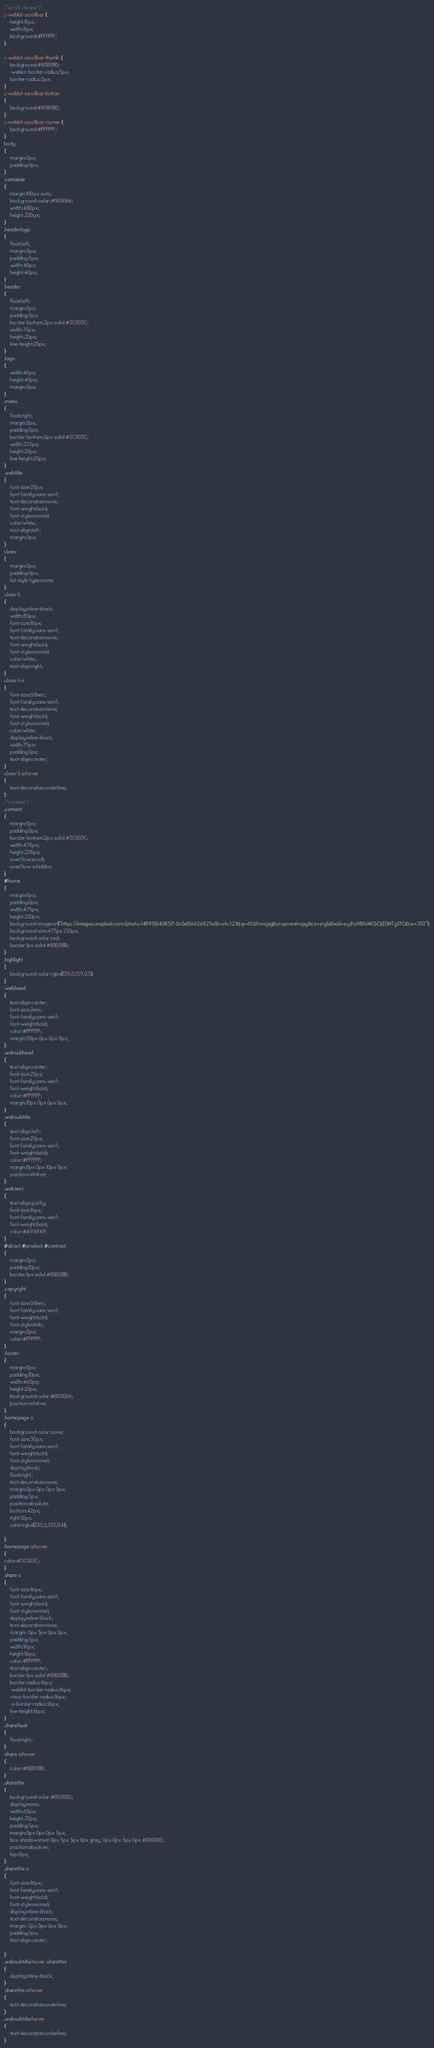Convert code to text. <code><loc_0><loc_0><loc_500><loc_500><_CSS_>/*scroll chrone*/
::-webkit-scrollbar {
    height:8px;
    width:8px;
    background:#FFFFFF;
}

::-webkit-scrollbar-thumb {
    background:#808080;
    -webkit-border-radius:5px;
    border-radius:5px;
}
::-webkit-scrollbar-button
{
	background:#808080;
}
::-webkit-scrollbar-corner {
    background:#FFFFFF;
}
body
{
	margin:0px;
	padding:0px;
}
.container
{
	margin:100px auto;
	background-color:#000066;
	width:480px;
	height:320px;
}
.headerlogo
{
	float:left;
	margin:0px;
	padding:5px;
	width:40px;
	height:40px;
}
.header
{
	float:left;
	margin:0px;
	padding:5px;
	border-bottom:2px solid #3C003C;
	width:75px;
	height:20px;
	line-height:20px;
}
.logo
{
	width:40px;
	height:40px;
	margin:0px;
}
.menu
{
	float:right;
	margin:0px;
	padding:5px;
	border-bottom:2px solid #3C003C;
	width:335px;
	height:20px;
	line-height:20px;
}
.webtitle
{
	font-size:20px;
	font-family:sans-serif;
	text-decoration:none;
	font-weight:bold;
	font-style:normal;
	color:white;
	text-align:left;
	margin:0px;
}
ul.nav
{
	margin:0px;
	padding:0px;
	list-style-type:none;
}
ul.nav li
{
	display:inline-block;
	width:80px;
	font-size:16px;
	font-family:sans-serif;
	text-decoration:none;
	font-weight:bold;
	font-style:normal;
	color:white;
	text-align:right;
}
ul.nav li a
{
	font-size:0.8em;
	font-family:sans-serif;
	text-decoration:none;
	font-weight:bold;
	font-style:normal;
	color:white;
	display:inline-block;
	width:75px;
	padding:0px;
	text-align:center;
}
ul.nav li a:hover
{
	text-decoration:underline;
}
/*content*/
.content
{
	margin:0px;
	padding:0px;
	border-bottom:2px solid #3C003C;
	width:478px;
	height:228px;
	overflow:scroll;
	overflow-x:hidden;
}
#home
{
	margin:0px;
	padding:0px;
	width:475px;
	height:250px;
	background-image:url("https://images.unsplash.com/photo-1489516408517-0c0a15662682?ixlib=rb-1.2.1&q=65&fm=jpg&crop=entropy&cs=srgb&ixid=eyJhcHBfaWQiOjE0NTg5fQ&w=350");
	background-size:475px 250px;
	background-color:red;
	border:1px solid #8B008B;
}
.highlight
{
	background-color:rgba(139,0,139,0.5);
}
.webhead
{
	text-align:center;
	font-size:2em;
	font-family:sans-serif;
	font-weight:bold;
	color:#FFFFFF;
	margin:50px 0px 0px 0px;
}
.websubhead
{
	text-align:center;
	font-size:25px;
	font-family:sans-serif;
	font-weight:bold;
	color:#FFFFFF;
	margin:10px 0px 0px 0px;
}
.websubtitle
{
	text-align:left;
	font-size:20px;
	font-family:sans-serif;
	font-weight:bold;
	color:#FFFFFF;
	margin:0px 0px 10px 0px;
	position:relative;
}
.webtext
{
	text-align:justify;
	font-size:16px;
	font-family:sans-serif;
	font-weight:bold;
	color:#A9A9A9;
}
#about,#product,#contract
{
	margin:0px;
	padding:10px;
	border:1px solid #8B008B;
}
.copyright
{
	font-size:0.8em;
	font-family:sans-serif;
	font-weight:bold;
	font-style:italic;
	margin:0px;
	color:#FFFFFF;
}
.footer
{
	margin:0px;
	padding:10px;
	width:460px;
	height:20px;
	background-color:#000066;
	position:relative;
}
.homepage a
{
	background-color:none;
	font-size:30px;
	font-family:sans-serif;
	font-weight:bold;
	font-style:normal;
	display:block;
	float:right;
	text-decoration:none;
	margin:0px 0px 0px 0px;
	padding:5px;
	position:absolute;
	bottom:42px;
	right:12px;
	color:rgba(255,0,255,0.4);
	
}
.homepage a:hover
{
color:#3C003C;
}
.share a
{
	font-size:16px;
	font-family:sans-serif;
	font-weight:bold;
	font-style:normal;
	display:inline-block;
	text-decoration:none;
	margin:-5px 5px 0px 0px;
	padding:5px;
	width:16px;
	height:16px;
	color:#FFFFFF;
	text-align:center;
	border:1px solid #8B008B;
	border-radius:16px;
	-webkit-border-radius:16px;
	-moz-border-radius:16px;
	-o-border-radius:16px;
	line-height:16px;
}
.sharefloat
{
	float:right;
}
.share a:hover
{
	color:#8B008B;
}
.sharethis
{
	background-color:#000000;
	display:none;
	width:60px;
	height:20px;
	padding:5px;
	margin:0px 0px 0px 5px;
	box-shadow:inset 0px 5px 5px 0px gray, 0px 0px 5px 0px #000000;
	position:absolute;
	top:0px;
}
.sharethis a
{
	font-size:16px;
	font-family:sans-serif;
	font-weight:bold;
	font-style:normal;
	display:inline-block;
	text-decoration:none;
	margin:-3px 0px 0px 0px;
	padding:5px;
	text-align:center;
	
}
.websubtitle:hover .sharethis
{
	display:inline-block;
}
.sharethis a:hover
{
	text-decoration:underline;
}
.websubtitle:hover
{
	text-decoration:underline;
}
</code> 